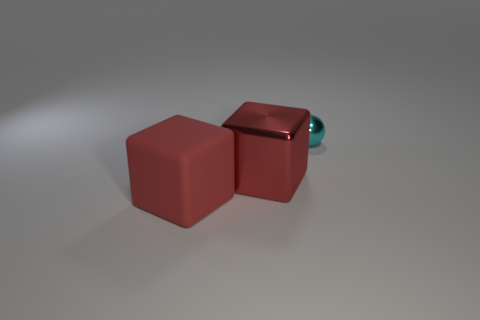What are the objects present in this image? The image contains two red cubes that appear to be identical in size and a small sphere with a shiny texture that has a teal or turquoise color. 